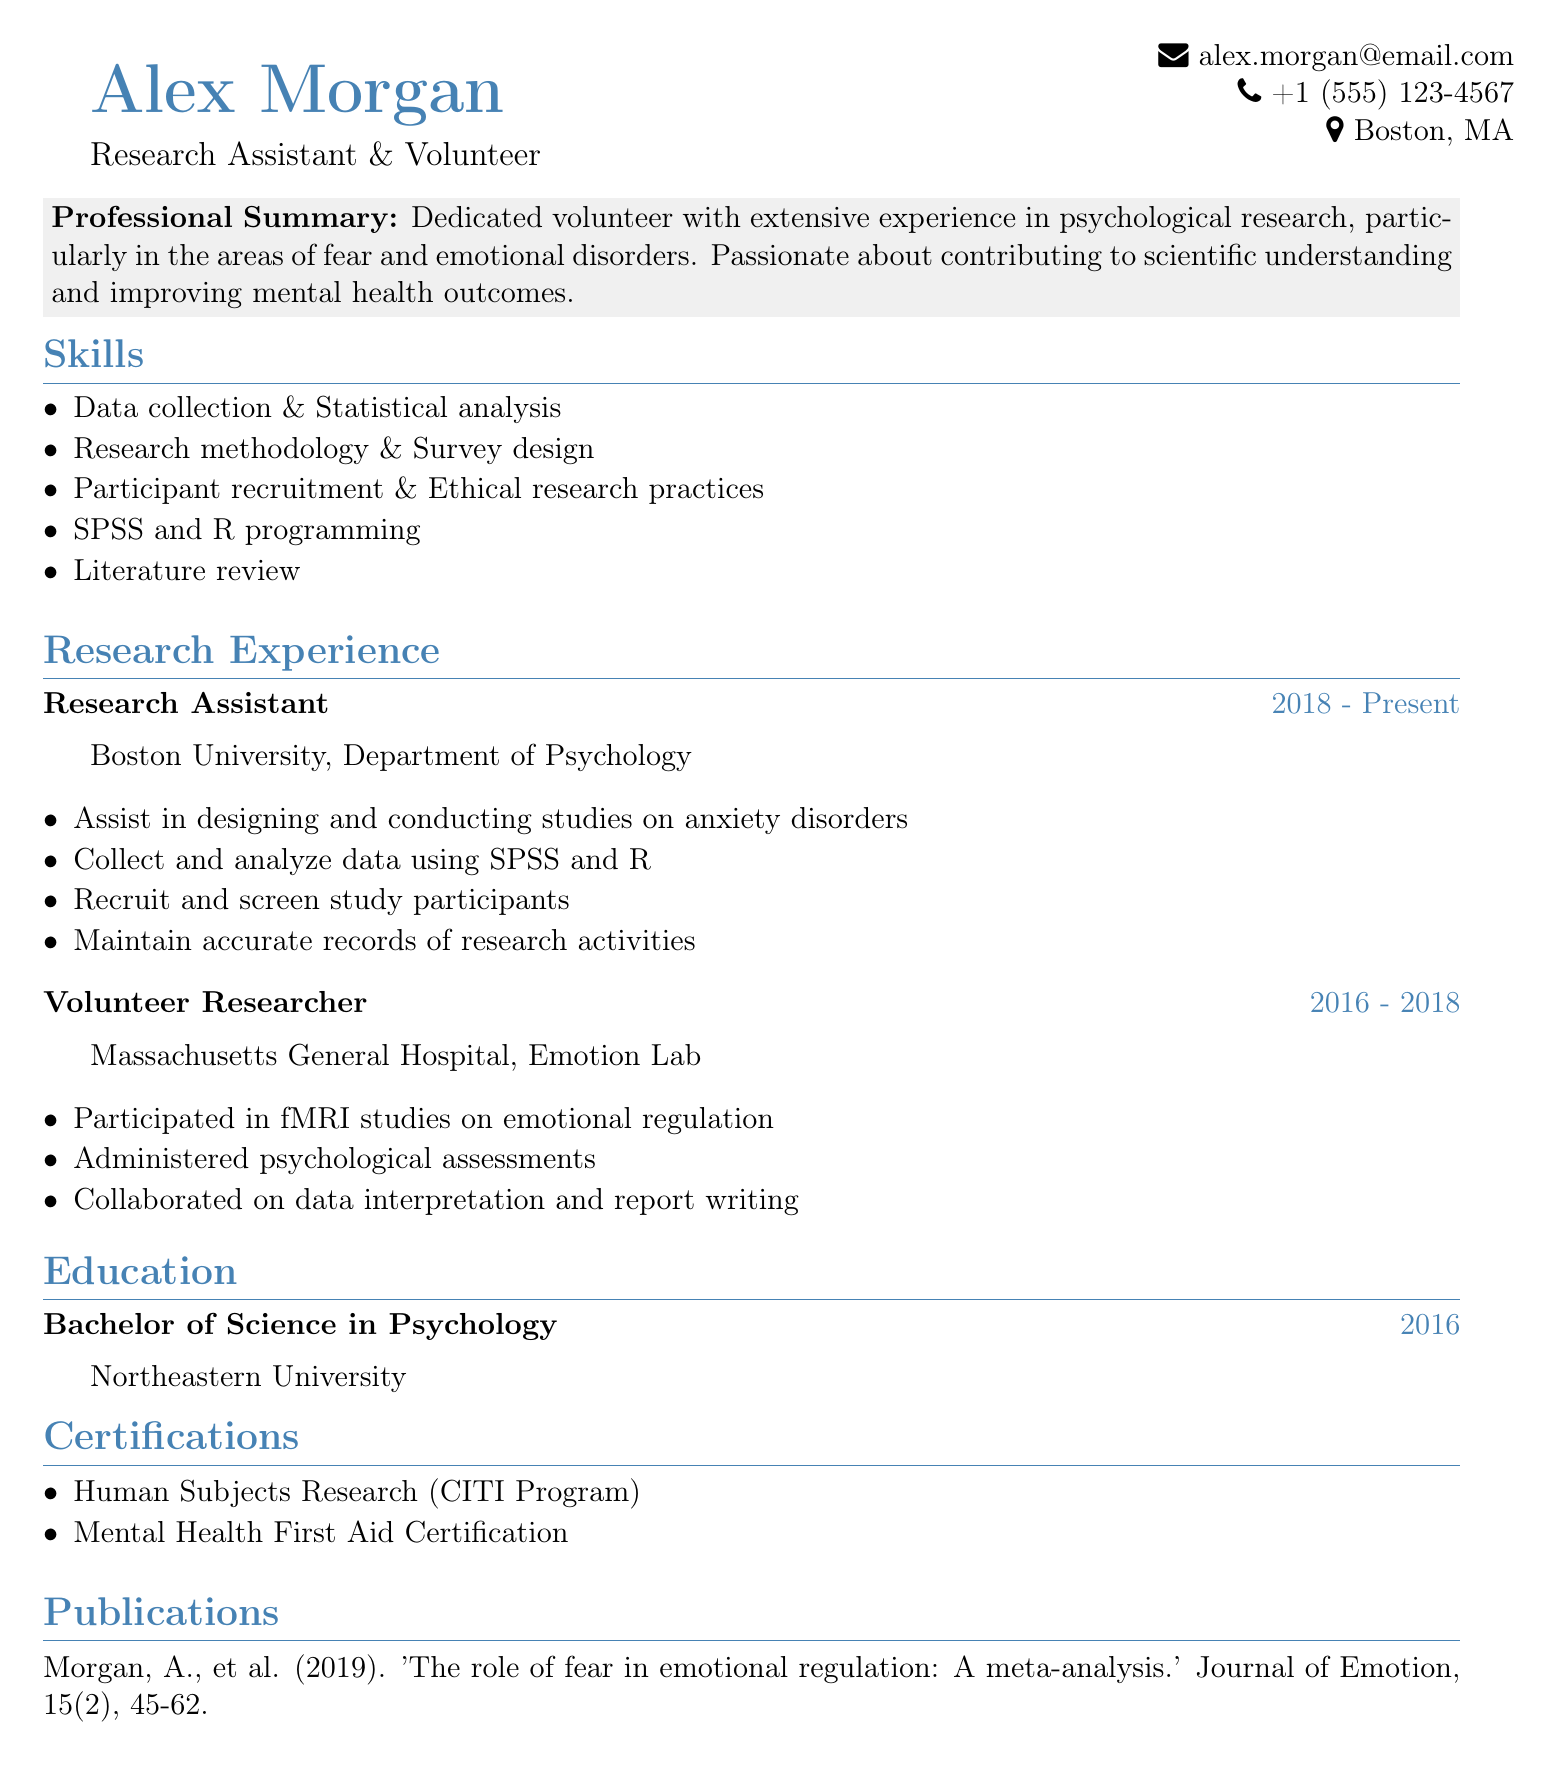What is the applicant's name? The applicant's name is prominently displayed at the top of the document.
Answer: Alex Morgan What degree did the applicant earn? The document specifies the applicant's degree in the education section.
Answer: Bachelor of Science in Psychology In which year did the applicant graduate? The graduation year is provided right below the degree information.
Answer: 2016 How long has the applicant been a Research Assistant? The duration of the applicant's role as a Research Assistant is stated in the work experience section.
Answer: 2018 - Present What programming languages does the applicant know? The skills section lists the programming knowledge of the applicant.
Answer: SPSS and R Which institution did the applicant volunteer at from 2016 to 2018? The details of the volunteer experience include the name of the institution where the applicant worked.
Answer: Massachusetts General Hospital What is one of the applicant's certifications? The certifications section lists qualifications earned by the applicant.
Answer: Human Subjects Research (CITI Program) What type of studies did the applicant assist with as a Research Assistant? The responsibilities section under research experience outlines the type of studies involved.
Answer: Anxiety disorders Name a publication by the applicant. The publications section mentions work credited to the applicant.
Answer: The role of fear in emotional regulation: A meta-analysis 